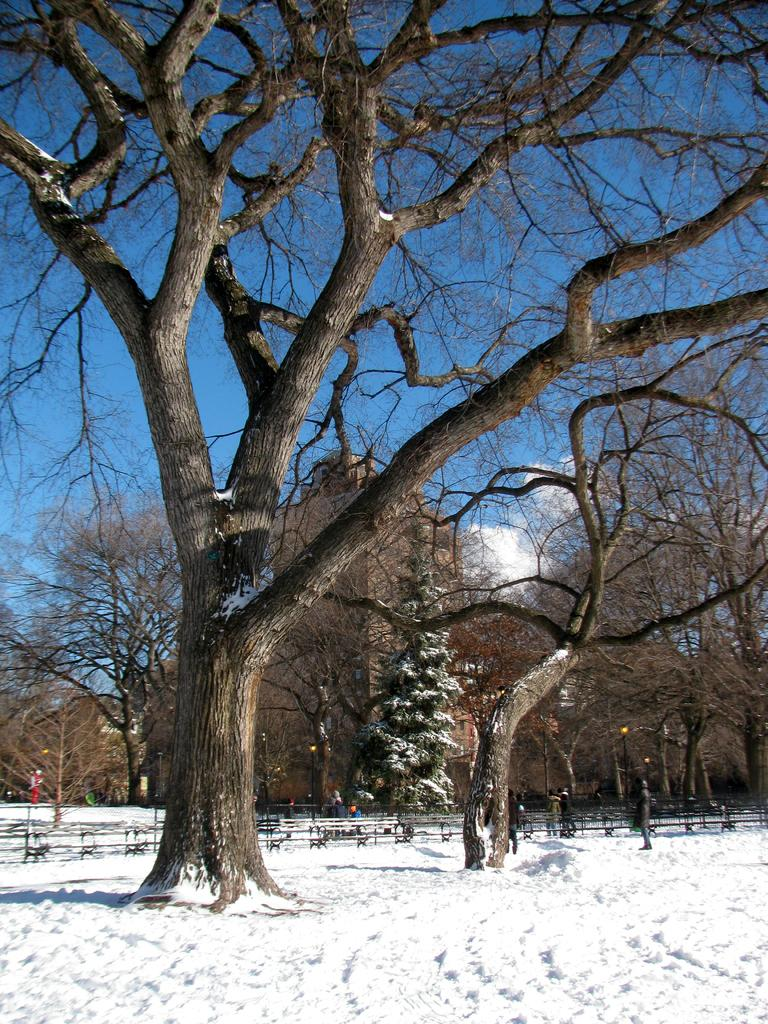What type of vegetation can be seen in the image? There are trees in the image. What is the weather like in the image? There is snow in the image, indicating a cold and likely wintery environment. Are any of the trees affected by the snow? Yes, some trees are covered with snow. What type of knife is being used to cut the oranges in the image? There are no knives or oranges present in the image; it features trees and snow. 